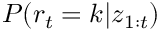<formula> <loc_0><loc_0><loc_500><loc_500>P ( r _ { t } = k | z _ { 1 \colon t } )</formula> 